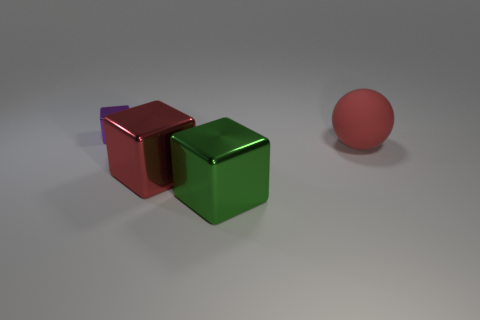The large object that is the same material as the big green cube is what color?
Offer a terse response. Red. Is there a metal object that has the same size as the matte ball?
Provide a short and direct response. Yes. What shape is the green metallic object that is the same size as the red matte ball?
Offer a very short reply. Cube. Is there a purple metal thing of the same shape as the large red metallic object?
Make the answer very short. Yes. Are there any shiny cylinders that have the same color as the matte thing?
Your response must be concise. No. What number of other things are the same material as the green cube?
Offer a terse response. 2. There is a tiny object; does it have the same color as the thing that is to the right of the green cube?
Offer a very short reply. No. Is the number of cubes right of the purple metallic cube greater than the number of small purple metallic cubes?
Give a very brief answer. Yes. There is a big red thing that is right of the big red object that is on the left side of the big red ball; how many tiny purple metallic things are right of it?
Your answer should be compact. 0. There is a big red object left of the red ball; is it the same shape as the red matte object?
Keep it short and to the point. No. 